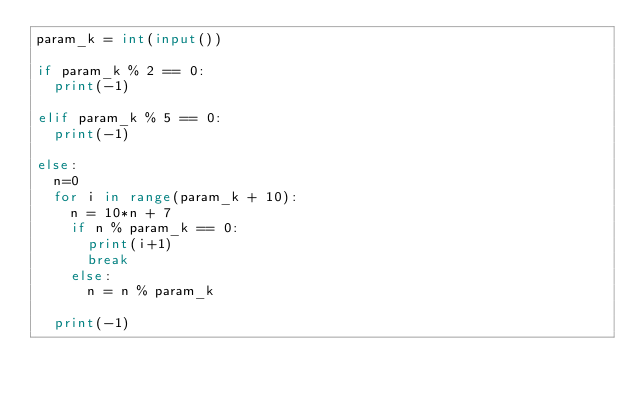Convert code to text. <code><loc_0><loc_0><loc_500><loc_500><_Python_>param_k = int(input())
    
if param_k % 2 == 0:
  print(-1)
  
elif param_k % 5 == 0:
  print(-1)
  
else:
  n=0
  for i in range(param_k + 10):
    n = 10*n + 7
    if n % param_k == 0:
      print(i+1)
      break
    else:
      n = n % param_k
  
  print(-1)</code> 